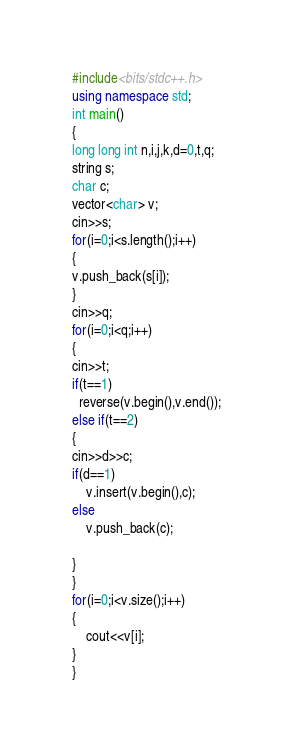Convert code to text. <code><loc_0><loc_0><loc_500><loc_500><_C++_>#include<bits/stdc++.h>
using namespace std;
int main()
{
long long int n,i,j,k,d=0,t,q;
string s;
char c;
vector<char> v;
cin>>s;
for(i=0;i<s.length();i++)
{
v.push_back(s[i]);
}
cin>>q;
for(i=0;i<q;i++)
{
cin>>t;
if(t==1)
  reverse(v.begin(),v.end());
else if(t==2)
{
cin>>d>>c;
if(d==1)
    v.insert(v.begin(),c);
else
    v.push_back(c);

}
}
for(i=0;i<v.size();i++)
{
    cout<<v[i];
}
}
</code> 